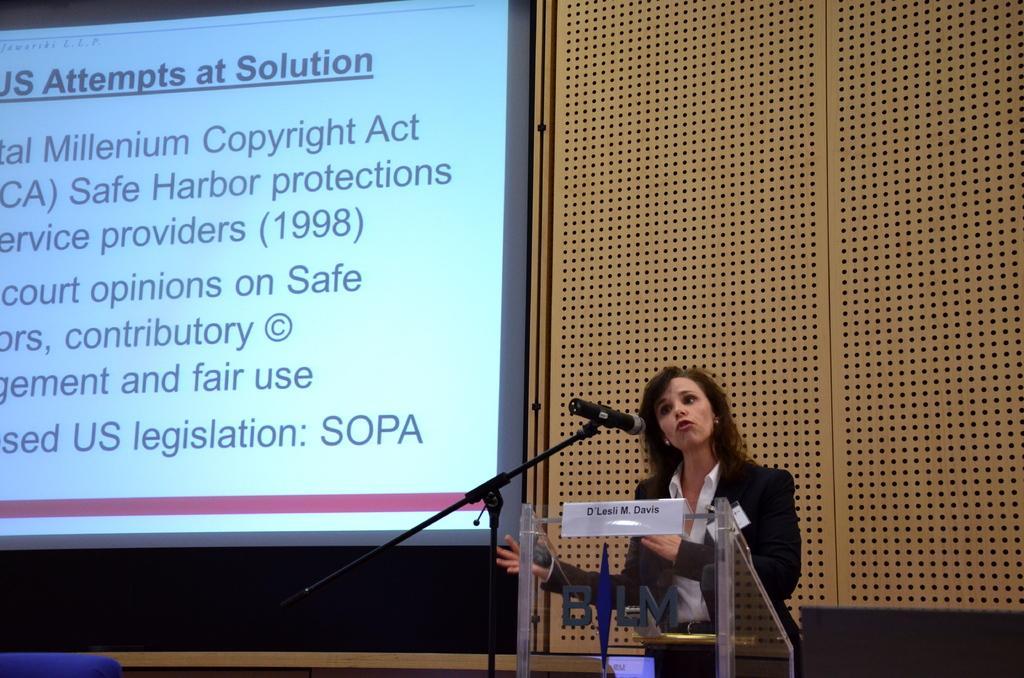Describe this image in one or two sentences. In this image I can see a lady standing beside the glass table and microphone stand, at the back there is a screen on the wall. 